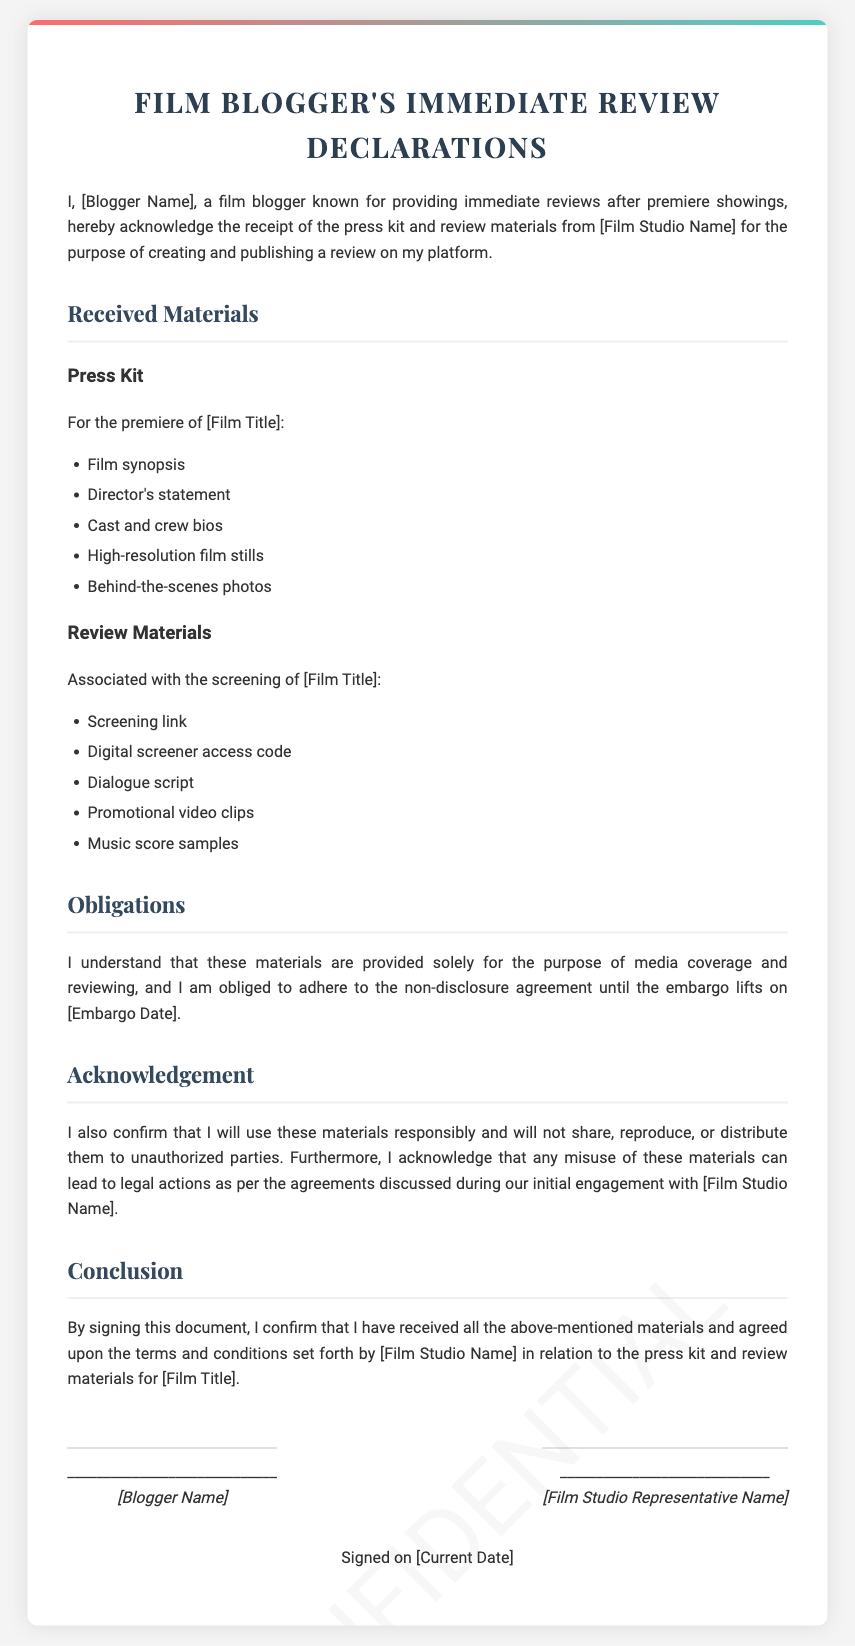What is the title of the document? The title of the document is presented in the header section, indicating it is a declaration for film bloggers.
Answer: Film Blogger's Immediate Review Declarations Who is the blogger acknowledging receipt of materials? The document includes a placeholder for the blogger's name indicating who is making the acknowledgment.
Answer: [Blogger Name] What type of materials are received? The document specifies the types of materials received in two main categories, which include press kit and review materials.
Answer: Press kit and review materials What is the purpose of receiving these materials? The document states the purpose of receiving these materials in the introduction section, which involves creating and publishing a review.
Answer: Creating and publishing a review What does the blogger confirm regarding material usage? The document specifies obligations regarding the usage of materials and their responsible handling by the blogger.
Answer: Use these materials responsibly What is the embargo date referred to in the document? The document contains a placeholder for the embargo date, indicating when the blogger can publicly disclose information.
Answer: [Embargo Date] Who must sign the document alongside the blogger? The document outlines that a representative from the film studio must also sign to acknowledge the agreement.
Answer: [Film Studio Representative Name] When is the document signed? The document mentions the current date as the date of signing, which will be specified when the document is finalized.
Answer: [Current Date] 